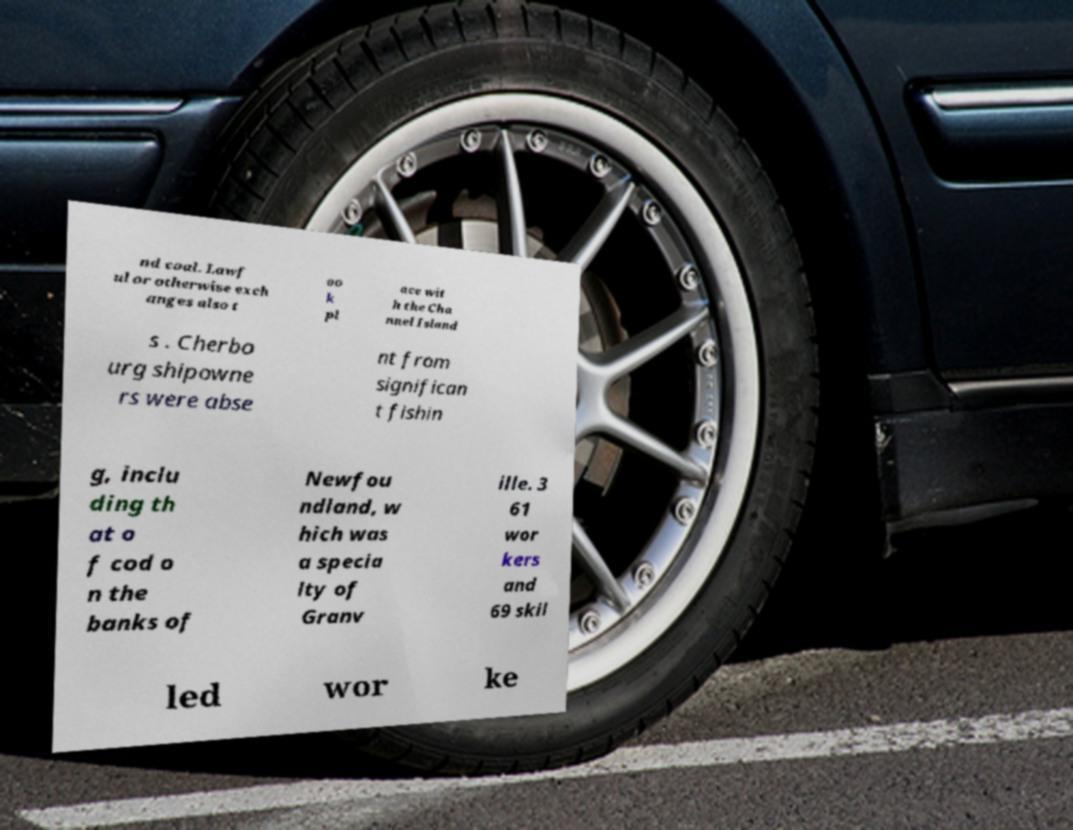I need the written content from this picture converted into text. Can you do that? nd coal. Lawf ul or otherwise exch anges also t oo k pl ace wit h the Cha nnel Island s . Cherbo urg shipowne rs were abse nt from significan t fishin g, inclu ding th at o f cod o n the banks of Newfou ndland, w hich was a specia lty of Granv ille. 3 61 wor kers and 69 skil led wor ke 